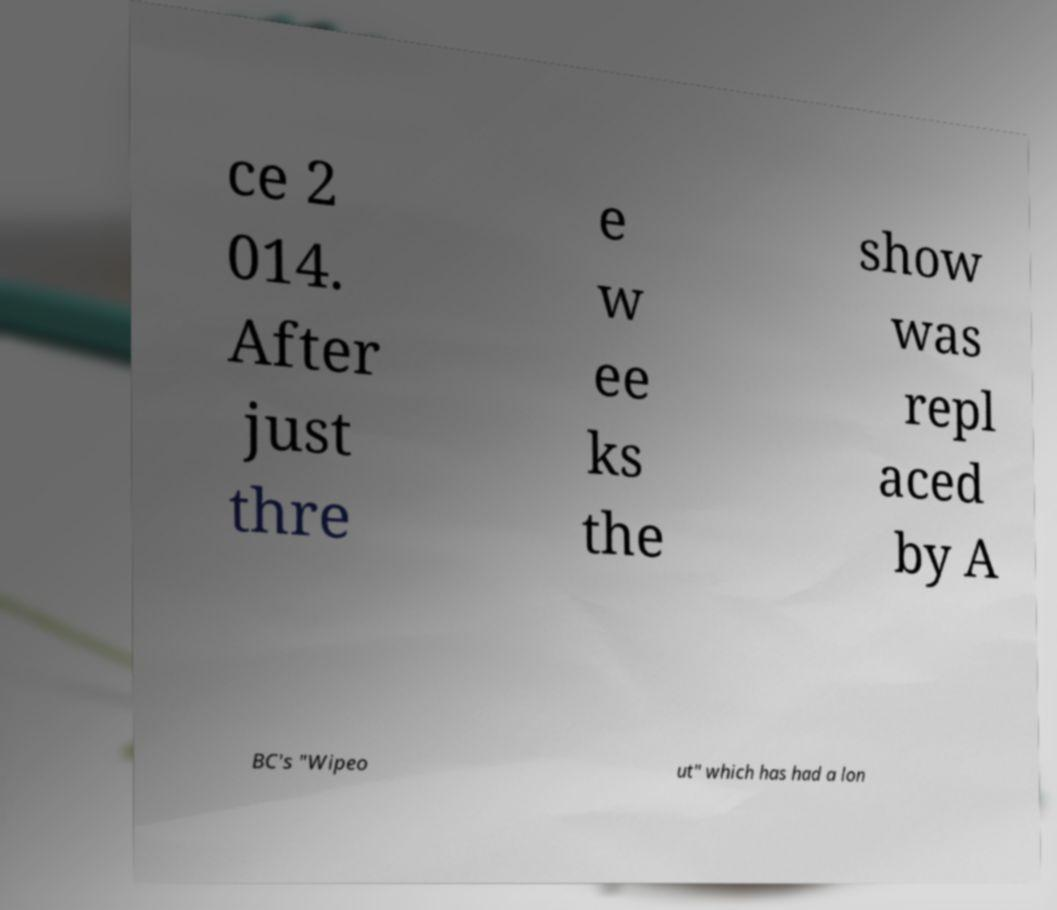I need the written content from this picture converted into text. Can you do that? ce 2 014. After just thre e w ee ks the show was repl aced by A BC's "Wipeo ut" which has had a lon 